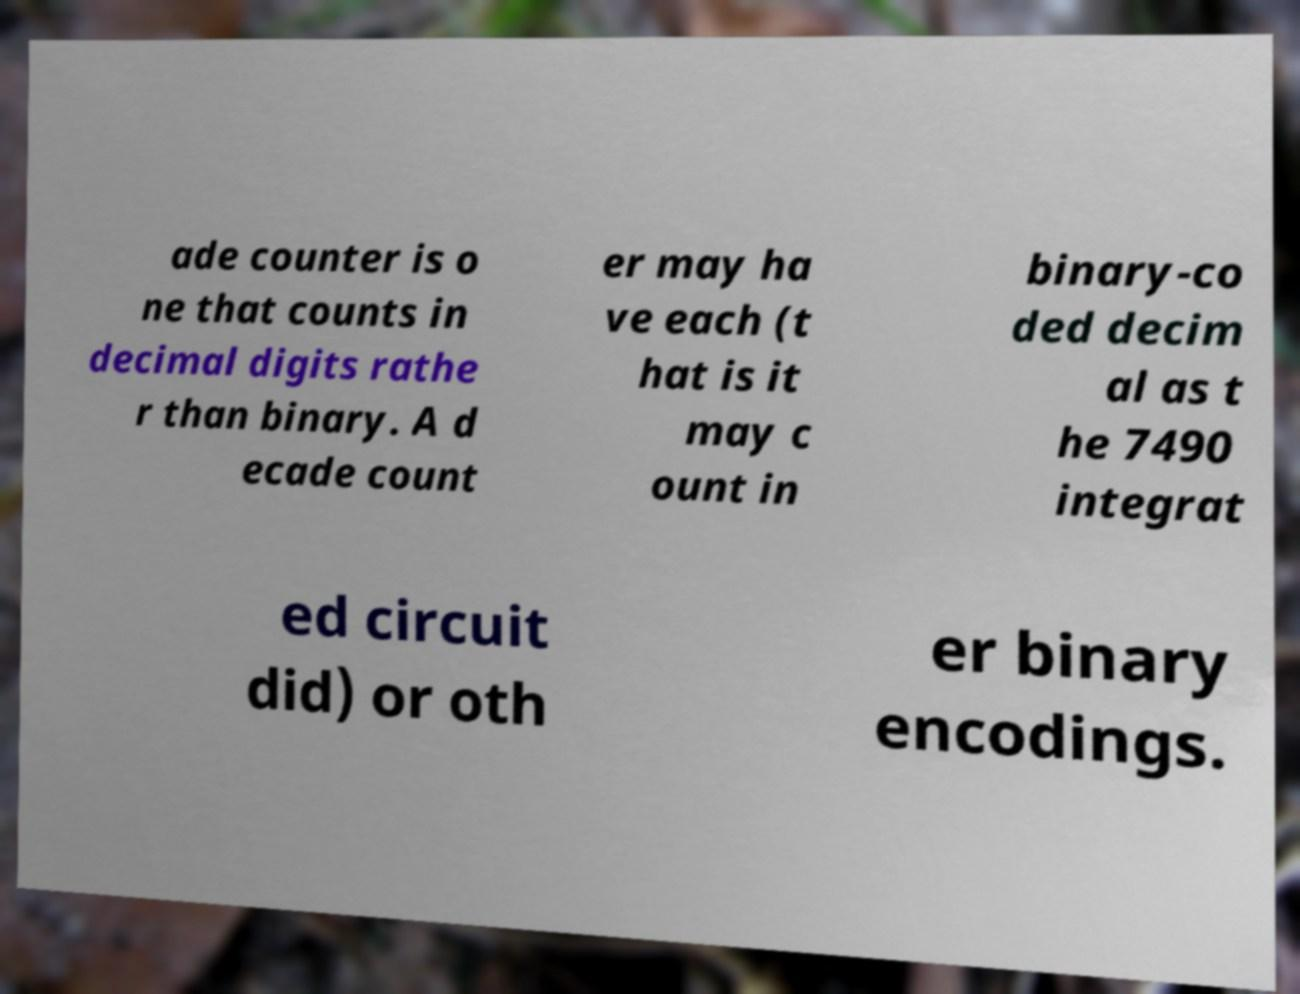For documentation purposes, I need the text within this image transcribed. Could you provide that? ade counter is o ne that counts in decimal digits rathe r than binary. A d ecade count er may ha ve each (t hat is it may c ount in binary-co ded decim al as t he 7490 integrat ed circuit did) or oth er binary encodings. 